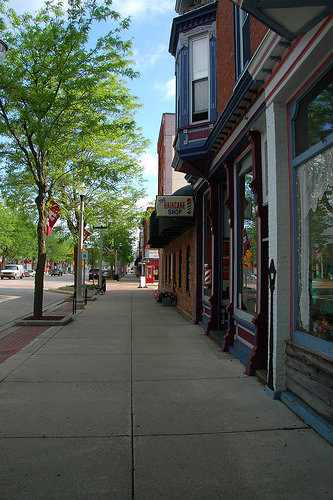<image>
Is the sign in the shop? No. The sign is not contained within the shop. These objects have a different spatial relationship. 